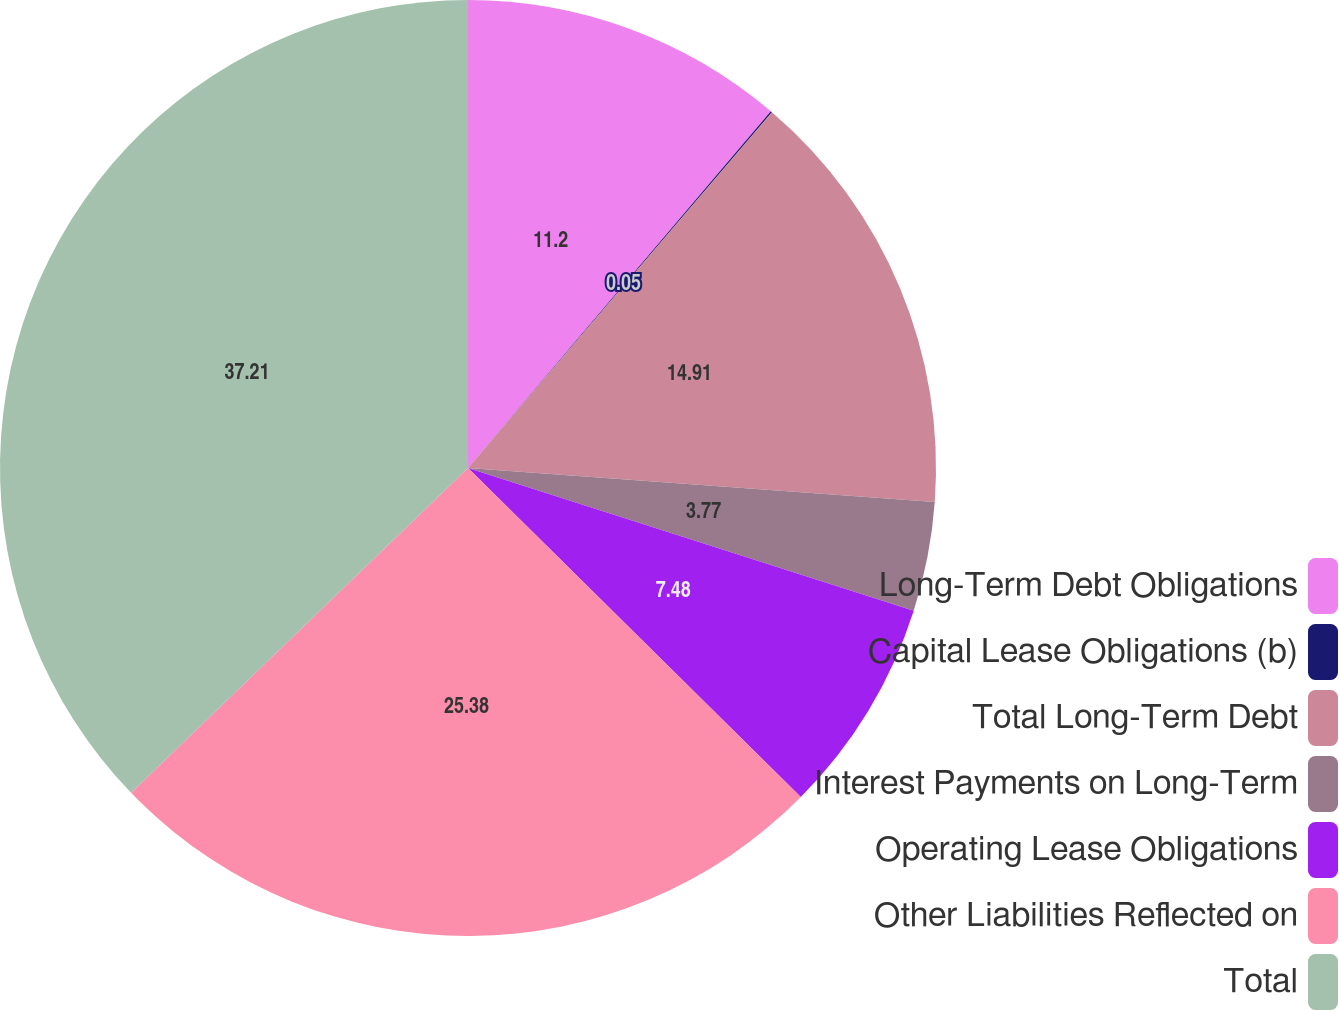<chart> <loc_0><loc_0><loc_500><loc_500><pie_chart><fcel>Long-Term Debt Obligations<fcel>Capital Lease Obligations (b)<fcel>Total Long-Term Debt<fcel>Interest Payments on Long-Term<fcel>Operating Lease Obligations<fcel>Other Liabilities Reflected on<fcel>Total<nl><fcel>11.2%<fcel>0.05%<fcel>14.91%<fcel>3.77%<fcel>7.48%<fcel>25.38%<fcel>37.21%<nl></chart> 